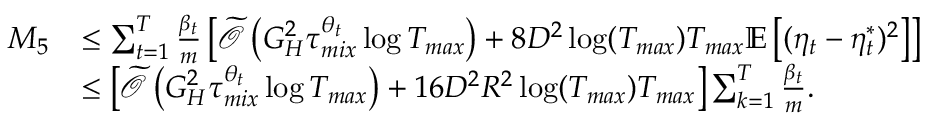<formula> <loc_0><loc_0><loc_500><loc_500>\begin{array} { r l } { M _ { 5 } } & { \leq \sum _ { t = 1 } ^ { T } \frac { \beta _ { t } } { m } \left [ \widetilde { \mathcal { O } } \left ( G _ { H } ^ { 2 } \tau _ { m i x } ^ { \theta _ { t } } \log T _ { \max } \right ) + 8 D ^ { 2 } \log ( T _ { \max } ) T _ { \max } \mathbb { E } \left [ ( \eta _ { t } - \eta _ { t } ^ { * } ) ^ { 2 } \right ] \right ] } \\ & { \leq \left [ \widetilde { \mathcal { O } } \left ( G _ { H } ^ { 2 } \tau _ { m i x } ^ { \theta _ { t } } \log T _ { \max } \right ) + 1 6 D ^ { 2 } R ^ { 2 } \log ( T _ { \max } ) T _ { \max } \right ] \sum _ { k = 1 } ^ { T } \frac { \beta _ { t } } { m } . } \end{array}</formula> 